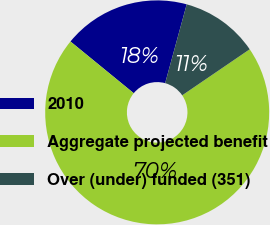Convert chart. <chart><loc_0><loc_0><loc_500><loc_500><pie_chart><fcel>2010<fcel>Aggregate projected benefit<fcel>Over (under) funded (351)<nl><fcel>18.34%<fcel>70.43%<fcel>11.23%<nl></chart> 